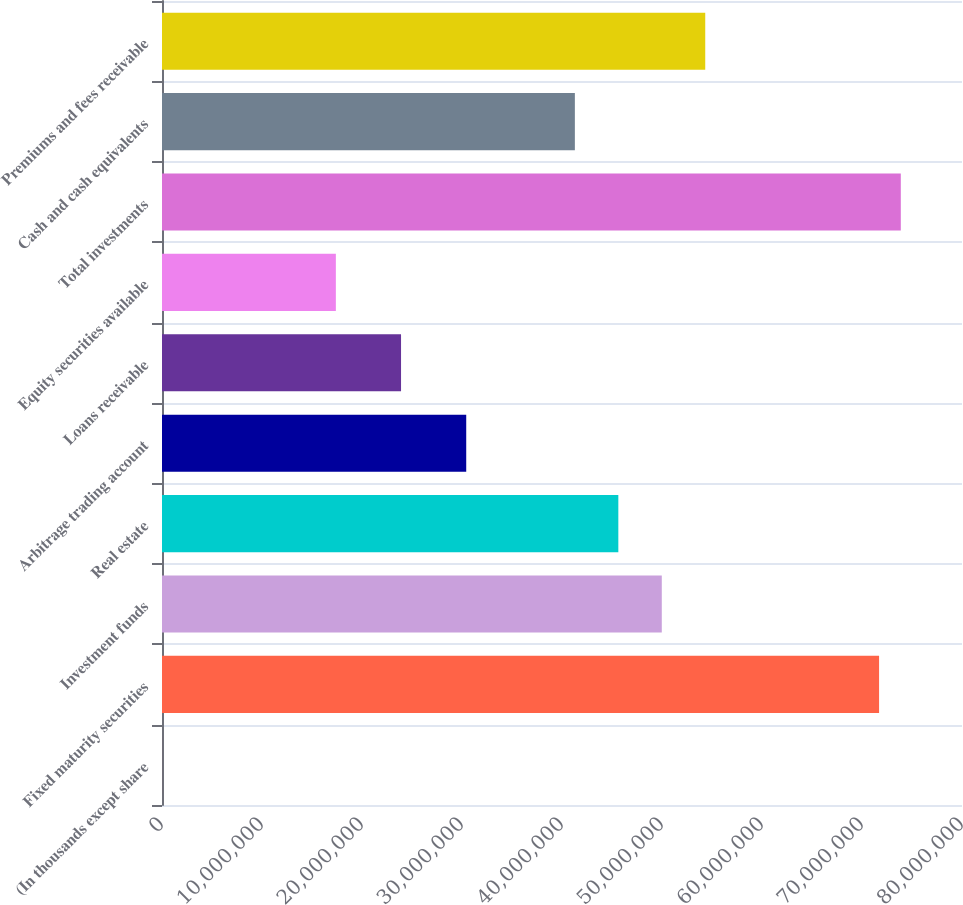Convert chart to OTSL. <chart><loc_0><loc_0><loc_500><loc_500><bar_chart><fcel>(In thousands except share<fcel>Fixed maturity securities<fcel>Investment funds<fcel>Real estate<fcel>Arbitrage trading account<fcel>Loans receivable<fcel>Equity securities available<fcel>Total investments<fcel>Cash and cash equivalents<fcel>Premiums and fees receivable<nl><fcel>2015<fcel>7.17076e+07<fcel>4.99786e+07<fcel>4.56328e+07<fcel>3.04225e+07<fcel>2.39039e+07<fcel>1.73852e+07<fcel>7.38805e+07<fcel>4.1287e+07<fcel>5.43244e+07<nl></chart> 